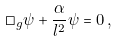<formula> <loc_0><loc_0><loc_500><loc_500>\Box _ { g } \psi + \frac { \alpha } { l ^ { 2 } } \psi = 0 \, ,</formula> 